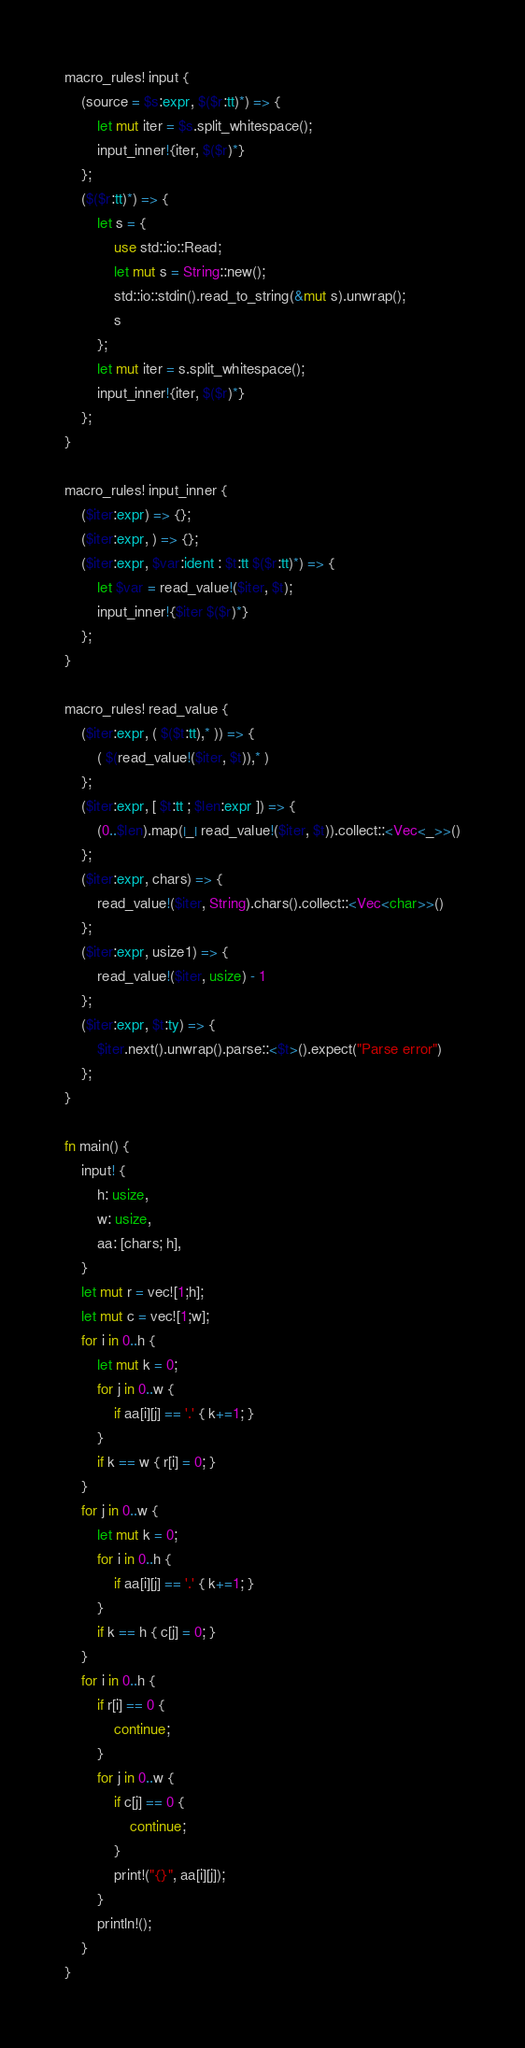Convert code to text. <code><loc_0><loc_0><loc_500><loc_500><_Rust_>macro_rules! input {
    (source = $s:expr, $($r:tt)*) => {
        let mut iter = $s.split_whitespace();
        input_inner!{iter, $($r)*}
    };
    ($($r:tt)*) => {
        let s = {
            use std::io::Read;
            let mut s = String::new();
            std::io::stdin().read_to_string(&mut s).unwrap();
            s
        };
        let mut iter = s.split_whitespace();
        input_inner!{iter, $($r)*}
    };
}

macro_rules! input_inner {
    ($iter:expr) => {};
    ($iter:expr, ) => {};
    ($iter:expr, $var:ident : $t:tt $($r:tt)*) => {
        let $var = read_value!($iter, $t);
        input_inner!{$iter $($r)*}
    };
}

macro_rules! read_value {
    ($iter:expr, ( $($t:tt),* )) => {
        ( $(read_value!($iter, $t)),* )
    };
    ($iter:expr, [ $t:tt ; $len:expr ]) => {
        (0..$len).map(|_| read_value!($iter, $t)).collect::<Vec<_>>()
    };
    ($iter:expr, chars) => {
        read_value!($iter, String).chars().collect::<Vec<char>>()
    };
    ($iter:expr, usize1) => {
        read_value!($iter, usize) - 1
    };
    ($iter:expr, $t:ty) => {
        $iter.next().unwrap().parse::<$t>().expect("Parse error")
    };
}

fn main() {
    input! {
        h: usize,
        w: usize,
        aa: [chars; h],
    }
    let mut r = vec![1;h];
    let mut c = vec![1;w];
    for i in 0..h {
        let mut k = 0;
        for j in 0..w {
            if aa[i][j] == '.' { k+=1; }
        }
        if k == w { r[i] = 0; }
    }
    for j in 0..w {
        let mut k = 0;
        for i in 0..h {
            if aa[i][j] == '.' { k+=1; }
        }
        if k == h { c[j] = 0; }
    }
    for i in 0..h {
        if r[i] == 0 {
            continue;
        }
        for j in 0..w {
            if c[j] == 0 {
                continue;
            }
            print!("{}", aa[i][j]);
        }
        println!();
    }
}
</code> 